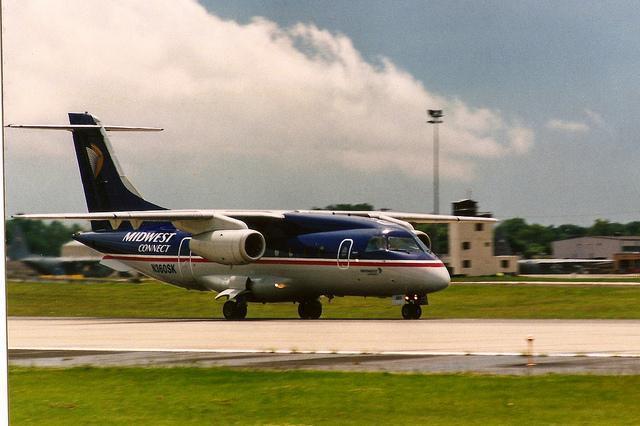How many wheels are on the plane?
Give a very brief answer. 3. How many birds are on the rock?
Give a very brief answer. 0. 